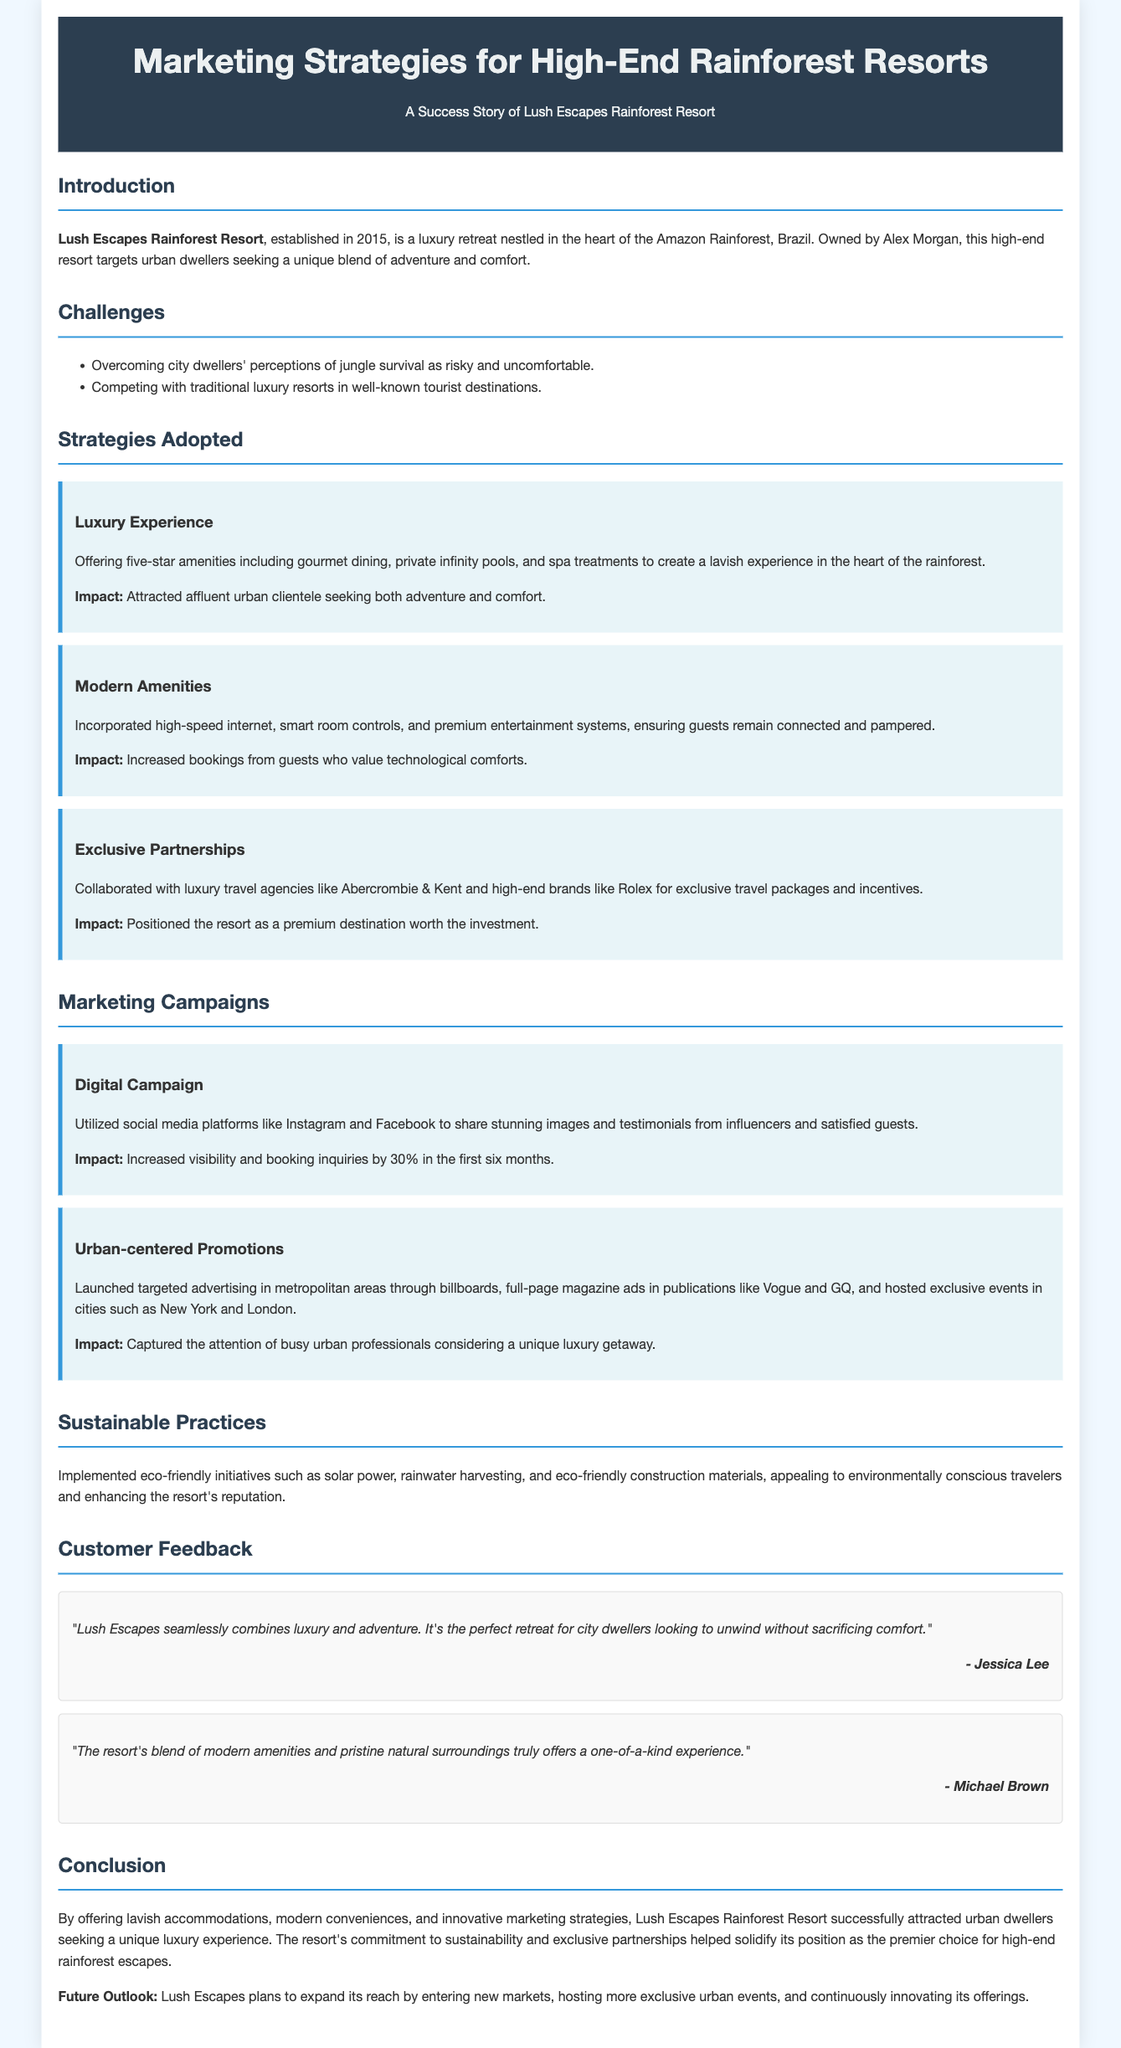what year was Lush Escapes established? The establishment year is mentioned in the introduction section of the document.
Answer: 2015 who owns Lush Escapes Rainforest Resort? The owner's name is stated in the introduction of the document.
Answer: Alex Morgan what type of clients does Lush Escapes target? This type of client is specified in the introduction section.
Answer: Urban dwellers what eco-friendly initiative is mentioned in the sustainability section? The sustainability section lists various initiatives, including one specific eco-friendly practice.
Answer: Solar power by what percentage did booking inquiries increase after the digital campaign? The impact of the digital campaign on booking inquiries is quantified in the marketing campaigns section.
Answer: 30% what advertising mediums were used for urban-centered promotions? The urban-centered promotions section lists several forms of advertising that were employed.
Answer: Billboards and magazines which travel agencies were mentioned in the exclusive partnerships? The exclusive partnerships section names specific agencies that collaborated with the resort.
Answer: Abercrombie & Kent what kind of amenities does the resort offer to attract guests? The amenities provided by the resort are detailed in the strategies adopted section.
Answer: Five-star amenities 